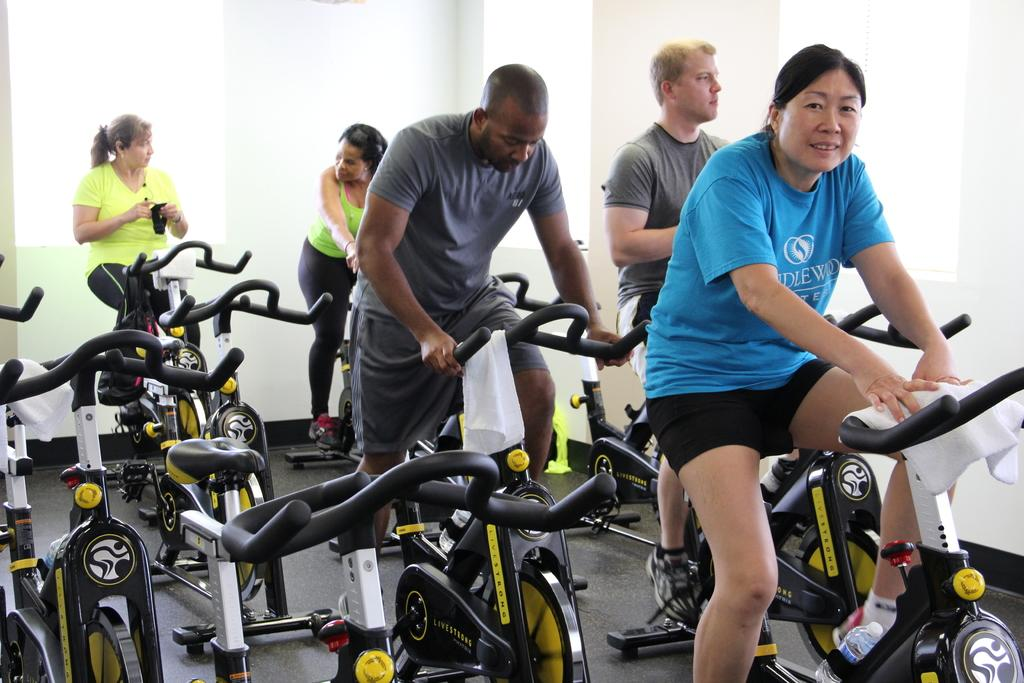What are the people in the image doing? The people in the image are cycling. What can be seen in the background of the image? There is a wall visible in the image. What color is the touch in the image? There is no touch present in the image, and therefore no color can be assigned to it. 